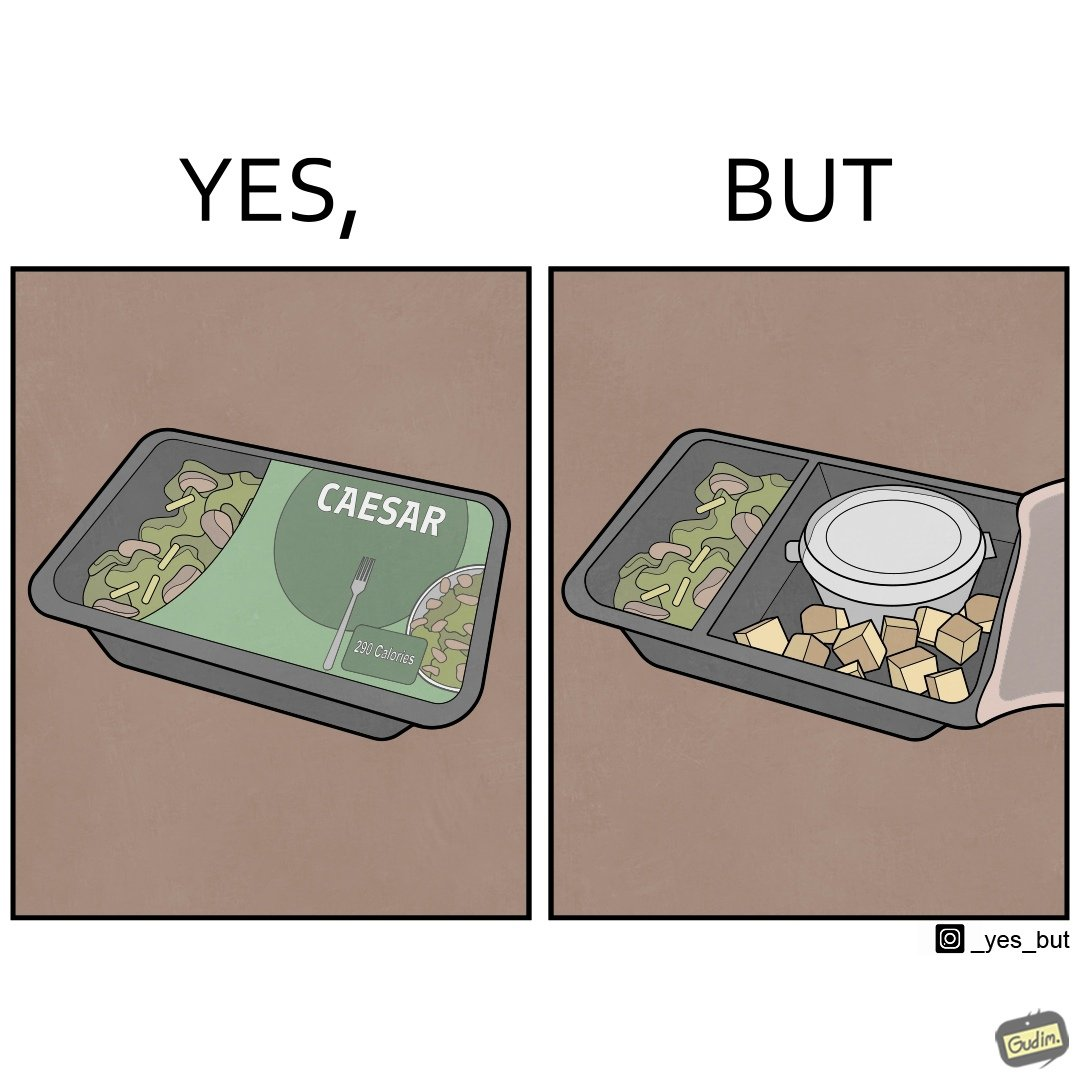Is this a satirical image? Yes, this image is satirical. 